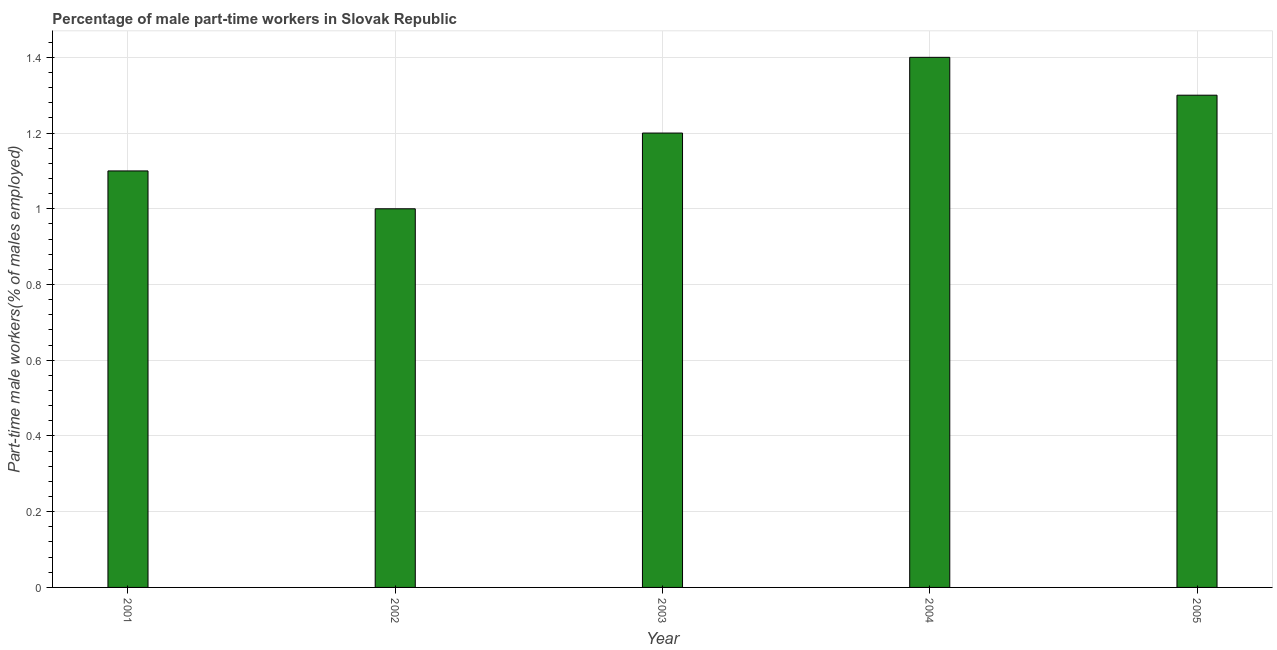Does the graph contain grids?
Offer a very short reply. Yes. What is the title of the graph?
Offer a terse response. Percentage of male part-time workers in Slovak Republic. What is the label or title of the Y-axis?
Keep it short and to the point. Part-time male workers(% of males employed). What is the percentage of part-time male workers in 2001?
Provide a short and direct response. 1.1. Across all years, what is the maximum percentage of part-time male workers?
Your response must be concise. 1.4. Across all years, what is the minimum percentage of part-time male workers?
Make the answer very short. 1. In which year was the percentage of part-time male workers maximum?
Your answer should be compact. 2004. In which year was the percentage of part-time male workers minimum?
Provide a short and direct response. 2002. What is the sum of the percentage of part-time male workers?
Your answer should be very brief. 6. What is the average percentage of part-time male workers per year?
Give a very brief answer. 1.2. What is the median percentage of part-time male workers?
Your answer should be very brief. 1.2. In how many years, is the percentage of part-time male workers greater than 0.8 %?
Your answer should be compact. 5. Do a majority of the years between 2002 and 2003 (inclusive) have percentage of part-time male workers greater than 1.2 %?
Make the answer very short. No. What is the ratio of the percentage of part-time male workers in 2003 to that in 2004?
Keep it short and to the point. 0.86. Is the difference between the percentage of part-time male workers in 2004 and 2005 greater than the difference between any two years?
Offer a very short reply. No. What is the difference between the highest and the lowest percentage of part-time male workers?
Ensure brevity in your answer.  0.4. How many bars are there?
Keep it short and to the point. 5. What is the difference between two consecutive major ticks on the Y-axis?
Your response must be concise. 0.2. What is the Part-time male workers(% of males employed) of 2001?
Offer a terse response. 1.1. What is the Part-time male workers(% of males employed) in 2002?
Your response must be concise. 1. What is the Part-time male workers(% of males employed) of 2003?
Provide a succinct answer. 1.2. What is the Part-time male workers(% of males employed) of 2004?
Provide a short and direct response. 1.4. What is the Part-time male workers(% of males employed) of 2005?
Ensure brevity in your answer.  1.3. What is the difference between the Part-time male workers(% of males employed) in 2001 and 2005?
Your response must be concise. -0.2. What is the difference between the Part-time male workers(% of males employed) in 2002 and 2003?
Provide a short and direct response. -0.2. What is the difference between the Part-time male workers(% of males employed) in 2002 and 2004?
Provide a short and direct response. -0.4. What is the difference between the Part-time male workers(% of males employed) in 2002 and 2005?
Provide a short and direct response. -0.3. What is the ratio of the Part-time male workers(% of males employed) in 2001 to that in 2002?
Provide a succinct answer. 1.1. What is the ratio of the Part-time male workers(% of males employed) in 2001 to that in 2003?
Offer a terse response. 0.92. What is the ratio of the Part-time male workers(% of males employed) in 2001 to that in 2004?
Provide a succinct answer. 0.79. What is the ratio of the Part-time male workers(% of males employed) in 2001 to that in 2005?
Your answer should be very brief. 0.85. What is the ratio of the Part-time male workers(% of males employed) in 2002 to that in 2003?
Provide a short and direct response. 0.83. What is the ratio of the Part-time male workers(% of males employed) in 2002 to that in 2004?
Offer a terse response. 0.71. What is the ratio of the Part-time male workers(% of males employed) in 2002 to that in 2005?
Keep it short and to the point. 0.77. What is the ratio of the Part-time male workers(% of males employed) in 2003 to that in 2004?
Provide a succinct answer. 0.86. What is the ratio of the Part-time male workers(% of males employed) in 2003 to that in 2005?
Offer a very short reply. 0.92. What is the ratio of the Part-time male workers(% of males employed) in 2004 to that in 2005?
Your answer should be compact. 1.08. 